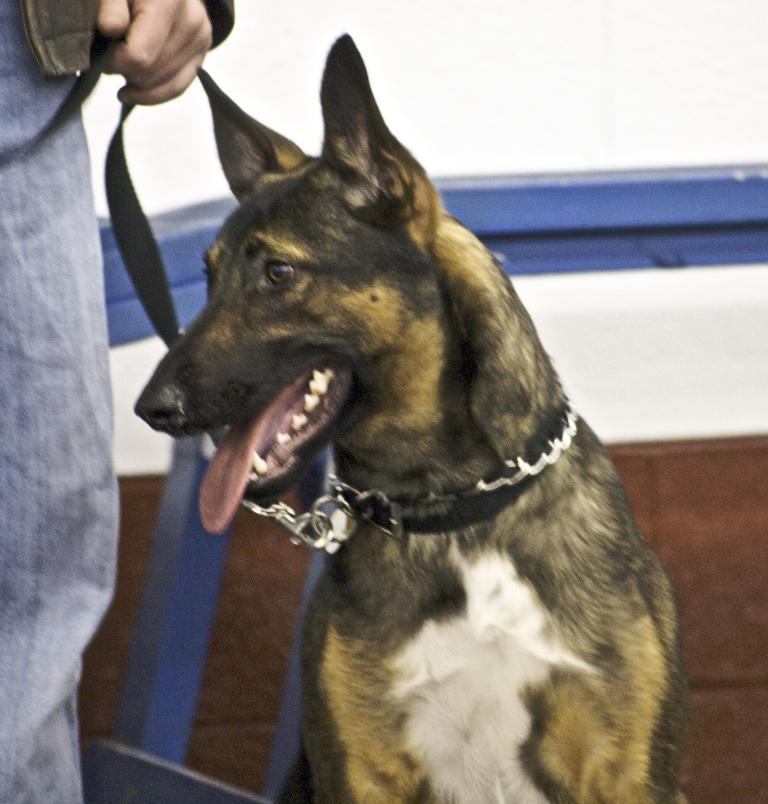Who or what is the main subject in the image? There is a person in the image. What is the person doing in the image? The person is holding a dog. What can be seen behind the person and the dog? There is a wall visible in the image. What is visible in the distance beyond the wall? The sky is visible in the background of the image. How many ants can be seen crawling on the person's arm in the image? There are no ants visible in the image; the person is holding a dog. 